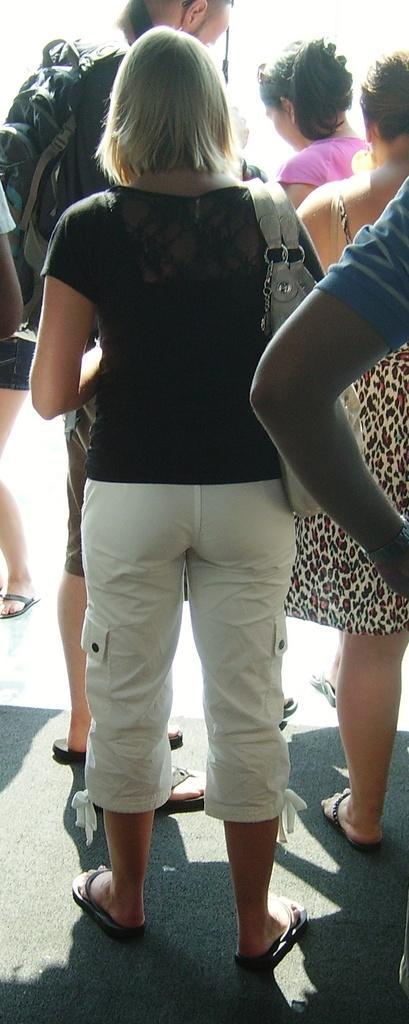Can you describe this image briefly? In this picture I can see there is a woman standing and wearing a black color shirt and a white pant. In the backdrop there are few other people standing. 